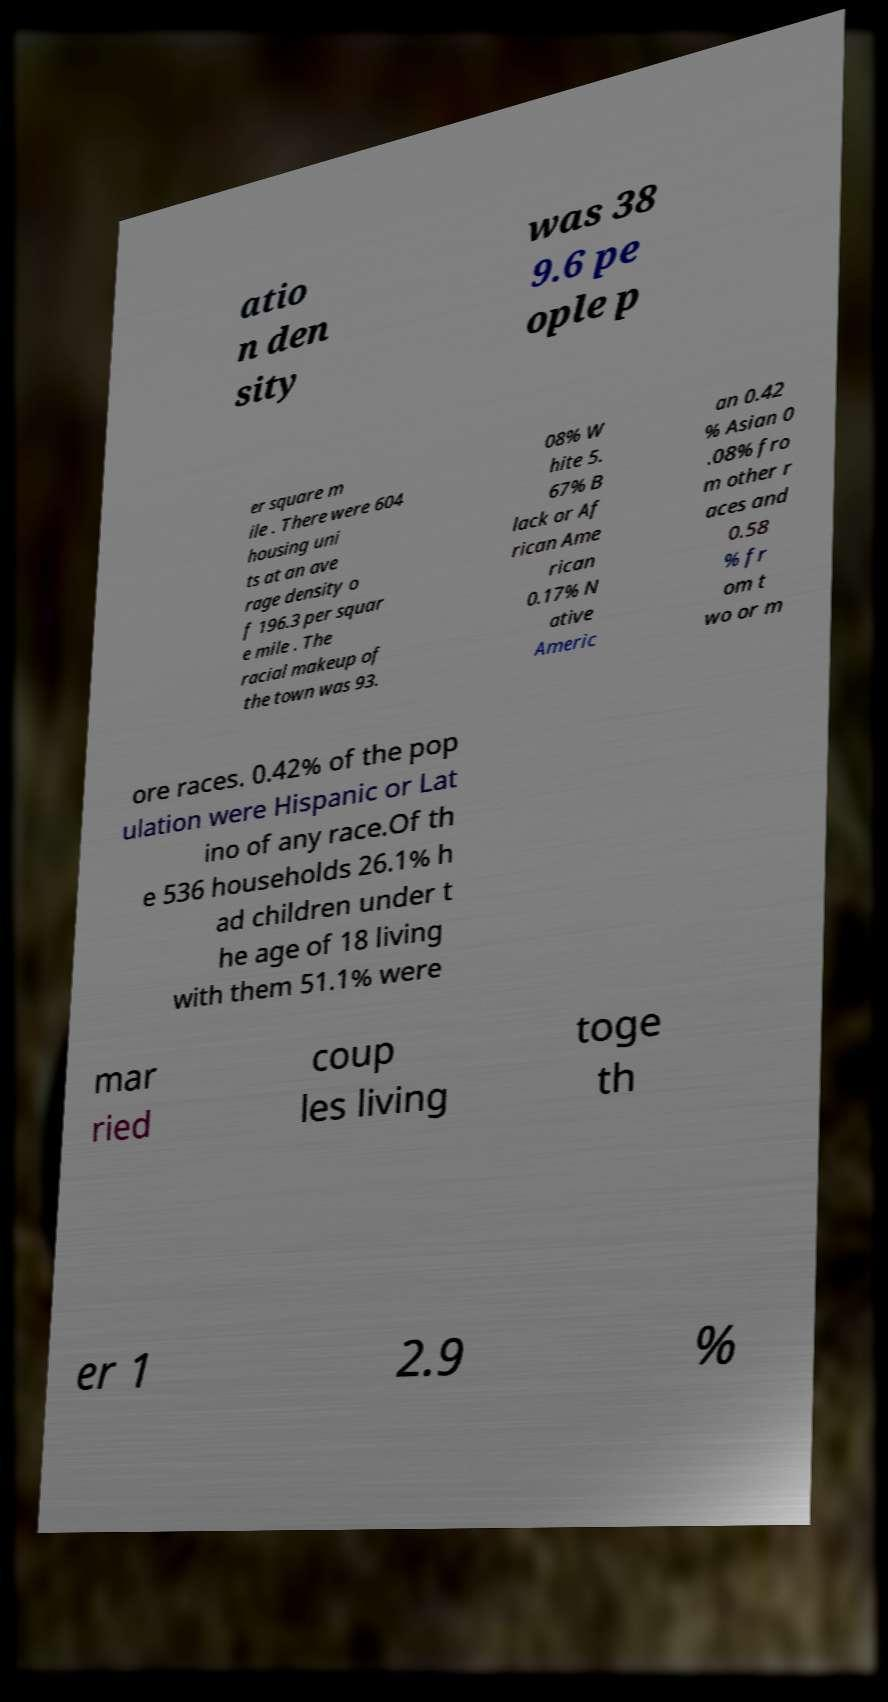What messages or text are displayed in this image? I need them in a readable, typed format. atio n den sity was 38 9.6 pe ople p er square m ile . There were 604 housing uni ts at an ave rage density o f 196.3 per squar e mile . The racial makeup of the town was 93. 08% W hite 5. 67% B lack or Af rican Ame rican 0.17% N ative Americ an 0.42 % Asian 0 .08% fro m other r aces and 0.58 % fr om t wo or m ore races. 0.42% of the pop ulation were Hispanic or Lat ino of any race.Of th e 536 households 26.1% h ad children under t he age of 18 living with them 51.1% were mar ried coup les living toge th er 1 2.9 % 